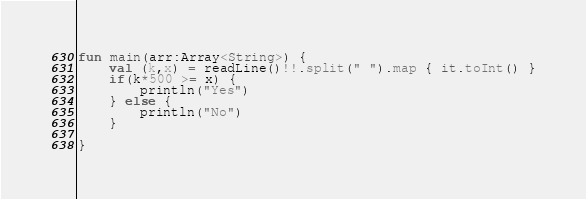<code> <loc_0><loc_0><loc_500><loc_500><_Kotlin_>

fun main(arr:Array<String>) {
    val (k,x) = readLine()!!.split(" ").map { it.toInt() }
    if(k*500 >= x) {
        println("Yes")
    } else {
        println("No")
    }

}


</code> 